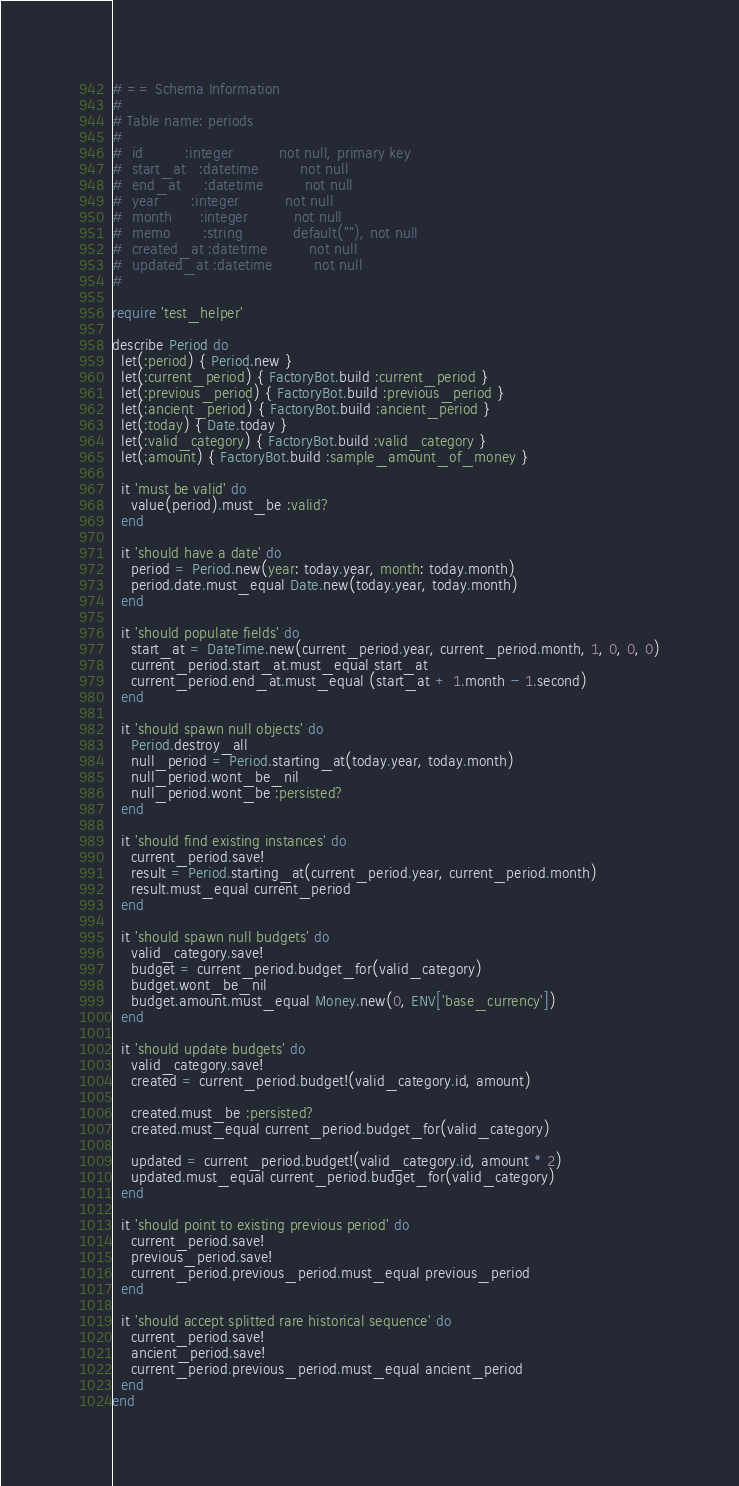Convert code to text. <code><loc_0><loc_0><loc_500><loc_500><_Ruby_># == Schema Information
#
# Table name: periods
#
#  id         :integer          not null, primary key
#  start_at   :datetime         not null
#  end_at     :datetime         not null
#  year       :integer          not null
#  month      :integer          not null
#  memo       :string           default(""), not null
#  created_at :datetime         not null
#  updated_at :datetime         not null
#

require 'test_helper'

describe Period do
  let(:period) { Period.new }
  let(:current_period) { FactoryBot.build :current_period }
  let(:previous_period) { FactoryBot.build :previous_period }
  let(:ancient_period) { FactoryBot.build :ancient_period }
  let(:today) { Date.today }
  let(:valid_category) { FactoryBot.build :valid_category }
  let(:amount) { FactoryBot.build :sample_amount_of_money }

  it 'must be valid' do
    value(period).must_be :valid?
  end

  it 'should have a date' do
    period = Period.new(year: today.year, month: today.month)
    period.date.must_equal Date.new(today.year, today.month)
  end

  it 'should populate fields' do
    start_at = DateTime.new(current_period.year, current_period.month, 1, 0, 0, 0)
    current_period.start_at.must_equal start_at
    current_period.end_at.must_equal (start_at + 1.month - 1.second)
  end

  it 'should spawn null objects' do
    Period.destroy_all
    null_period = Period.starting_at(today.year, today.month)
    null_period.wont_be_nil
    null_period.wont_be :persisted?
  end

  it 'should find existing instances' do
    current_period.save!
    result = Period.starting_at(current_period.year, current_period.month)
    result.must_equal current_period
  end

  it 'should spawn null budgets' do
    valid_category.save!
    budget = current_period.budget_for(valid_category)
    budget.wont_be_nil
    budget.amount.must_equal Money.new(0, ENV['base_currency'])
  end

  it 'should update budgets' do
    valid_category.save!
    created = current_period.budget!(valid_category.id, amount)

    created.must_be :persisted?
    created.must_equal current_period.budget_for(valid_category)

    updated = current_period.budget!(valid_category.id, amount * 2)
    updated.must_equal current_period.budget_for(valid_category)
  end

  it 'should point to existing previous period' do
    current_period.save!
    previous_period.save!
    current_period.previous_period.must_equal previous_period
  end

  it 'should accept splitted rare historical sequence' do
    current_period.save!
    ancient_period.save!
    current_period.previous_period.must_equal ancient_period
  end
end
</code> 